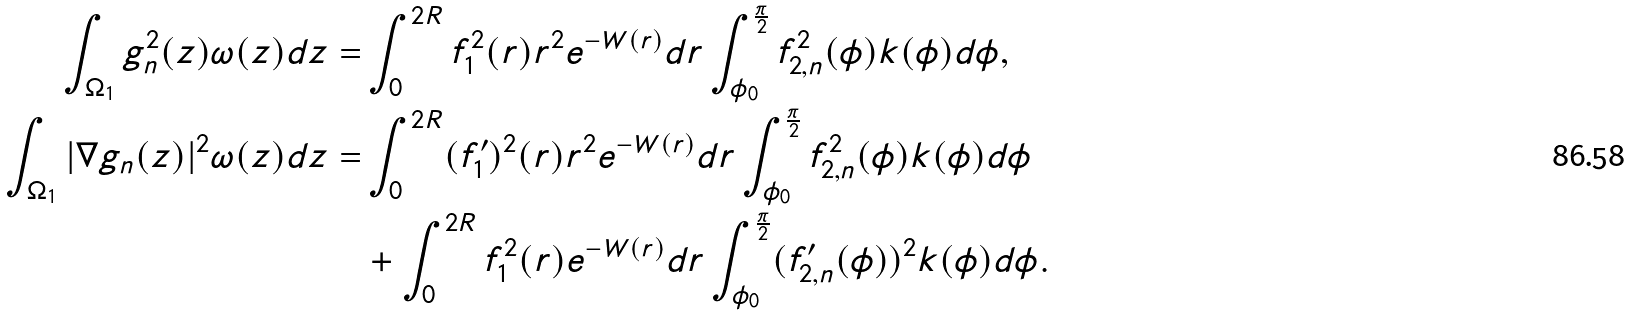<formula> <loc_0><loc_0><loc_500><loc_500>\int _ { \Omega _ { 1 } } g _ { n } ^ { 2 } ( z ) \omega ( z ) d z = & \int _ { 0 } ^ { 2 R } f ^ { 2 } _ { 1 } ( r ) r ^ { 2 } e ^ { - W ( r ) } d r \int _ { \phi _ { 0 } } ^ { \frac { \pi } { 2 } } f ^ { 2 } _ { 2 , n } ( \phi ) k ( \phi ) d \phi , \\ \int _ { \Omega _ { 1 } } | \nabla g _ { n } ( z ) | ^ { 2 } \omega ( z ) d z = & \int _ { 0 } ^ { 2 R } ( f ^ { \prime } _ { 1 } ) ^ { 2 } ( r ) r ^ { 2 } e ^ { - W ( r ) } d r \int _ { \phi _ { 0 } } ^ { \frac { \pi } { 2 } } f ^ { 2 } _ { 2 , n } ( \phi ) k ( \phi ) d \phi \\ & + \int _ { 0 } ^ { 2 R } f ^ { 2 } _ { 1 } ( r ) e ^ { - W ( r ) } d r \int _ { \phi _ { 0 } } ^ { \frac { \pi } { 2 } } ( f ^ { \prime } _ { 2 , n } ( \phi ) ) ^ { 2 } k ( \phi ) d \phi .</formula> 